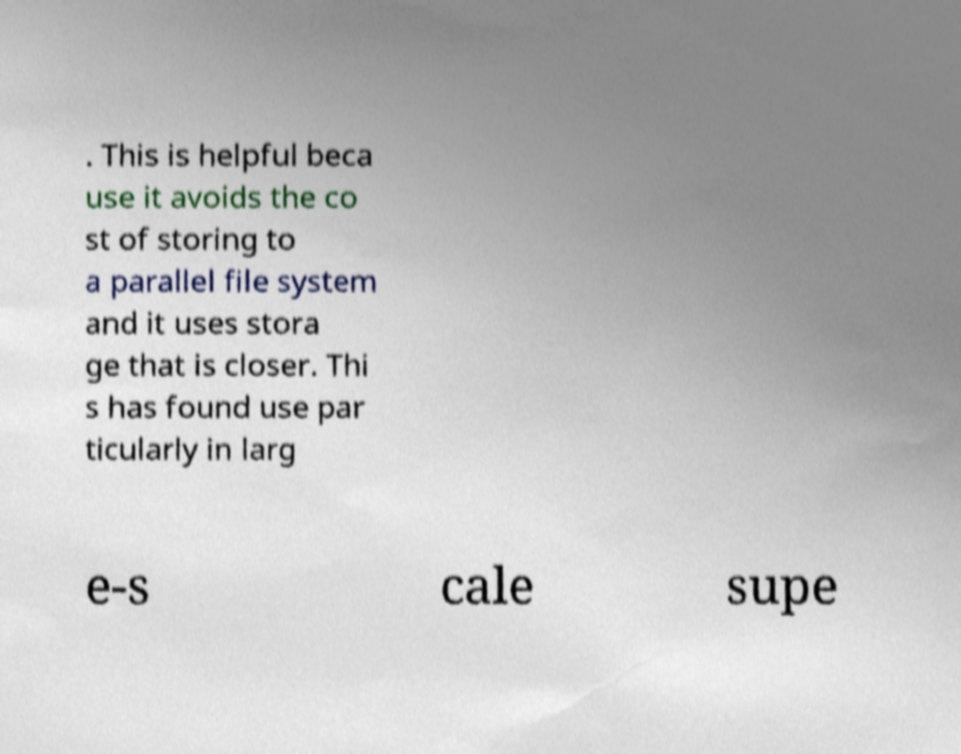There's text embedded in this image that I need extracted. Can you transcribe it verbatim? . This is helpful beca use it avoids the co st of storing to a parallel file system and it uses stora ge that is closer. Thi s has found use par ticularly in larg e-s cale supe 